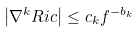<formula> <loc_0><loc_0><loc_500><loc_500>\left | \nabla ^ { k } R i c \right | \leq c _ { k } f ^ { - b _ { k } }</formula> 